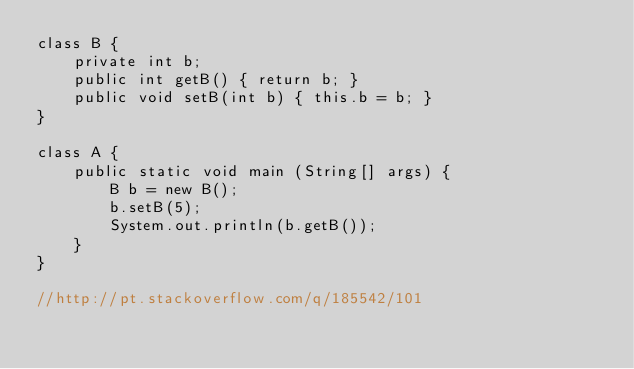<code> <loc_0><loc_0><loc_500><loc_500><_Java_>class B {
    private int b;
    public int getB() { return b; }
    public void setB(int b) { this.b = b; }
}

class A {
    public static void main (String[] args) {
        B b = new B();
        b.setB(5);
        System.out.println(b.getB());
    }
}

//http://pt.stackoverflow.com/q/185542/101
</code> 